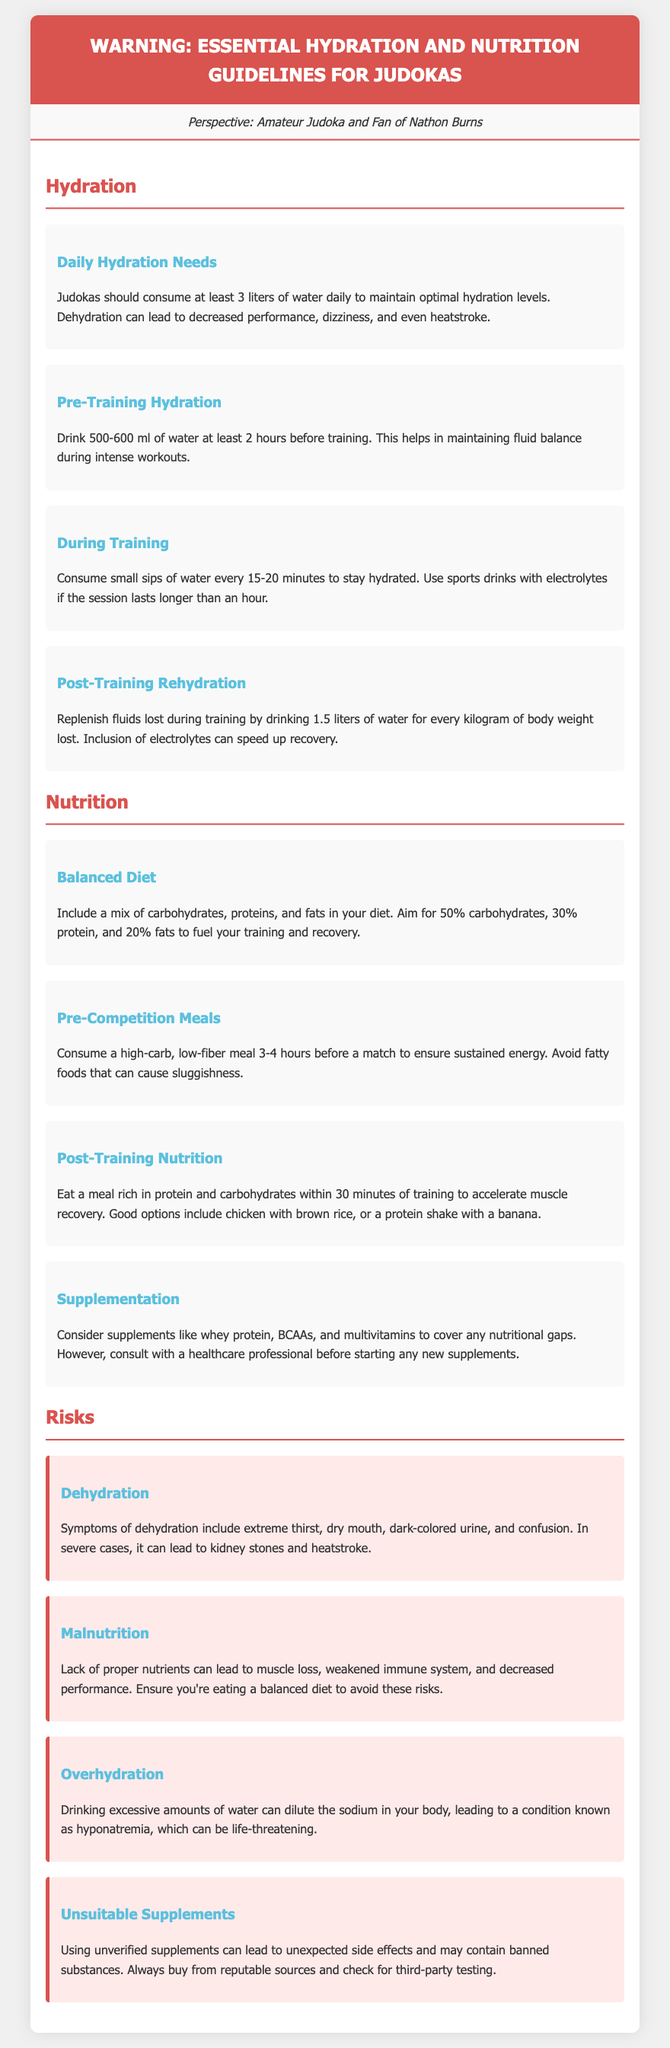what is the daily water intake for judokas? Judokas should consume at least 3 liters of water daily to maintain optimal hydration levels.
Answer: 3 liters how much water should be consumed before training? Drink 500-600 ml of water at least 2 hours before training.
Answer: 500-600 ml what percentage of a judoka's diet should be carbohydrates? Aim for 50% carbohydrates, 30% protein, and 20% fats to fuel your training and recovery.
Answer: 50% what is a symptom of dehydration? Symptoms of dehydration include extreme thirst, dry mouth, dark-colored urine, and confusion.
Answer: extreme thirst what meal should be consumed 3-4 hours before a match? Consume a high-carb, low-fiber meal to ensure sustained energy.
Answer: high-carb, low-fiber meal what is the recommended hydration after training? Drink 1.5 liters of water for every kilogram of body weight lost.
Answer: 1.5 liters what are the risks of unsuitable supplements? Using unverified supplements can lead to unexpected side effects and may contain banned substances.
Answer: unexpected side effects what should be included in post-training nutrition? Eat a meal rich in protein and carbohydrates within 30 minutes of training.
Answer: protein and carbohydrates 